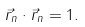<formula> <loc_0><loc_0><loc_500><loc_500>\vec { r } _ { n } \cdot \vec { r } _ { n } = 1 .</formula> 